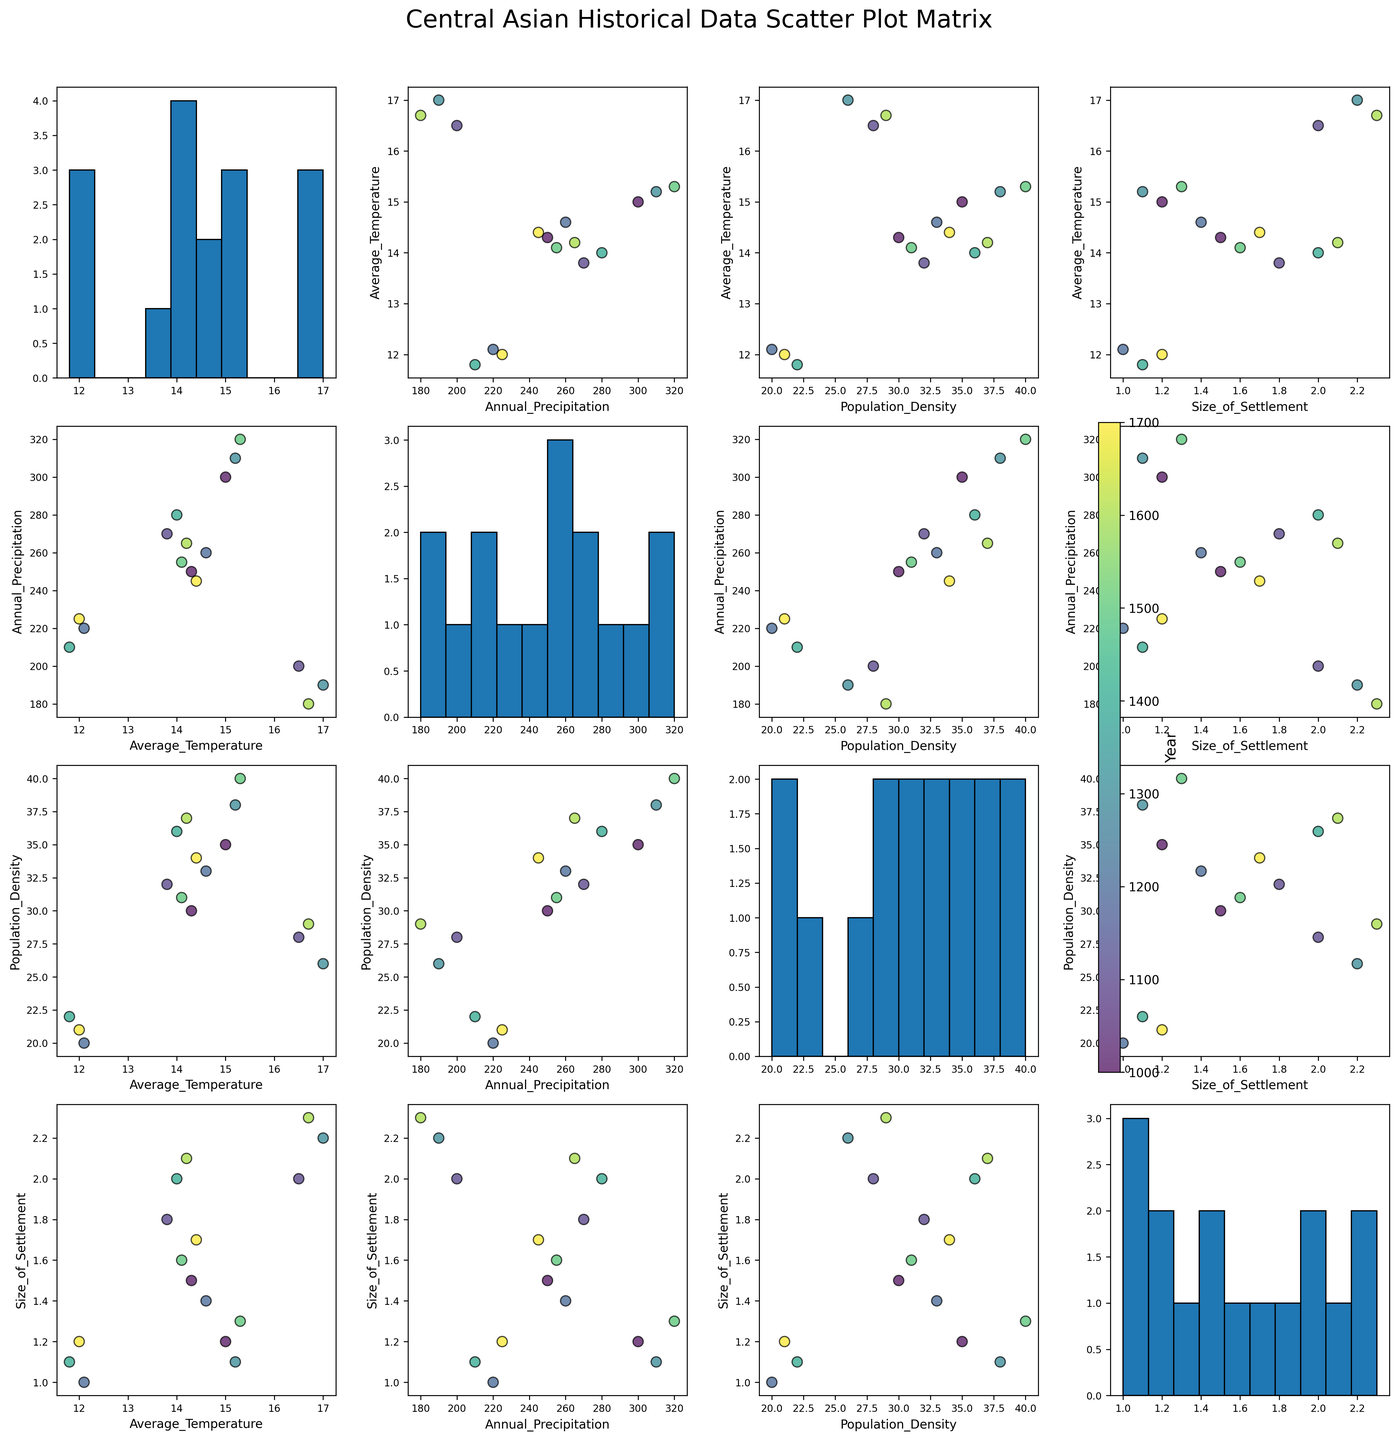How many numeric variables are depicted in this scatter plot matrix? The matrix shows plots of different numeric variables. By examining the axes, we see four numerical variables: Average Temperature, Annual Precipitation, Population Density, and Size of Settlement.
Answer: 4 Which numeric variable has a histogram with the highest peak? In the scatter plot matrix, diagonals contain histograms for each numeric variable. Identifying the histogram with the largest peak, we see it corresponds to Annual Precipitation.
Answer: Annual Precipitation What is the general relationship between Population Density and Size of Settlement? Observing the scatter plot for Population Density vs. Size of Settlement, data points show a positive correlation, meaning higher population density generally corresponds with larger settlements.
Answer: Positive correlation Which region and time period combination has the highest Average Temperature? Data points in the scatter plot matrix are color-coded by year. The scatter plot of Year vs. Average Temperature reveals the highest temperature is observed in the 1300s in Bactria.
Answer: 1300s, Bactria How does Annual Precipitation relate to Population Density? Looking at the Population Density vs. Annual Precipitation plot, we see a generally positive relationship, where regions with higher precipitation tend to have higher population densities.
Answer: Positive relationship Describe the trends in Population Density over time. In scatter plots showing Year vs. Population Density, we can observe an increasing trend in Population Density over time, from initially lower values to higher values as time progresses.
Answer: Increasing trend Compare the size of settlements in Fergana Valley between the years 1300 and 1500. To answer this, observe the scatter plot of Size of Settlement vs. Year. Focus on the points for the Fergana Valley, noting the size is approximately 1.1 sq km in 1300 and 1.3 sq km in 1500, indicating an increase.
Answer: Increase from 1.1 to 1.3 sq km Which numeric variable appears to have the most variability in its values based on the histograms? Examining the widths of the distributions in the histograms, Population Density appears the most spread out, indicating the highest variability.
Answer: Population Density 